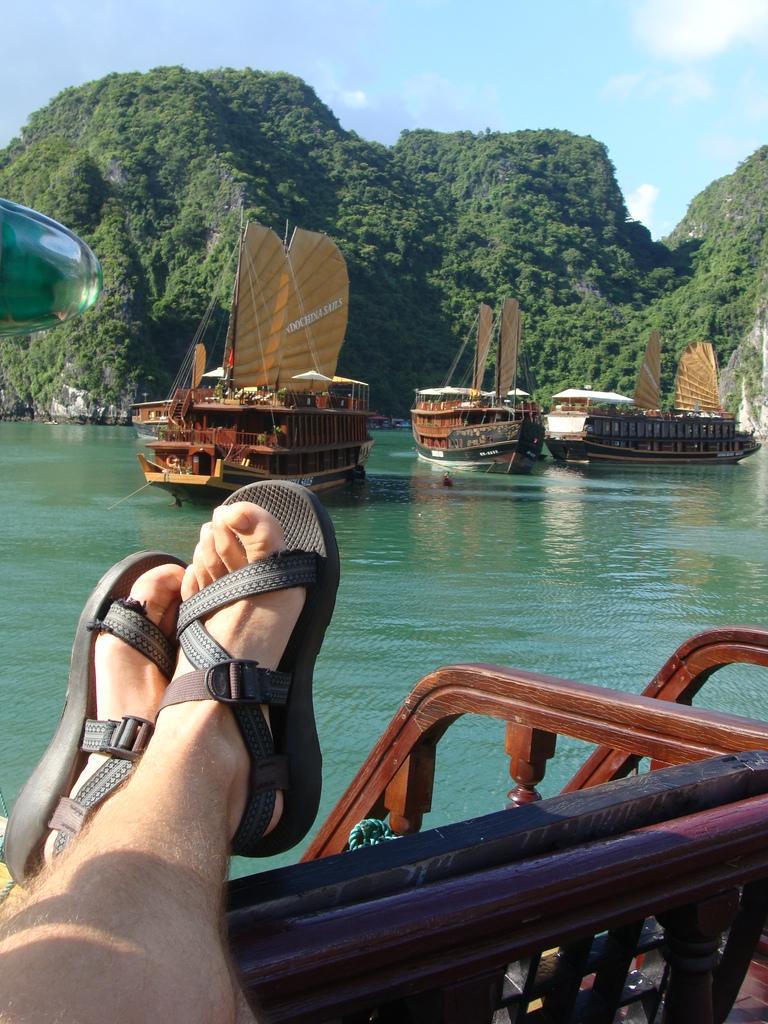In one or two sentences, can you explain what this image depicts? In the center of the image a boats are present. In the background of the image trees are there. In the middle of the image water is present. At the bottom left corner a person legs are there. At the top of the image sky is present. 